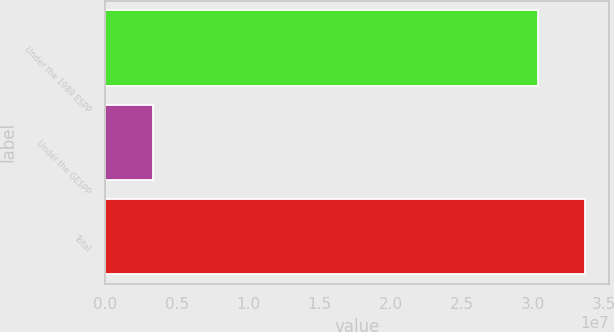<chart> <loc_0><loc_0><loc_500><loc_500><bar_chart><fcel>Under the 1989 ESPP<fcel>Under the GESPP<fcel>Total<nl><fcel>3.03547e+07<fcel>3.31405e+06<fcel>3.36688e+07<nl></chart> 